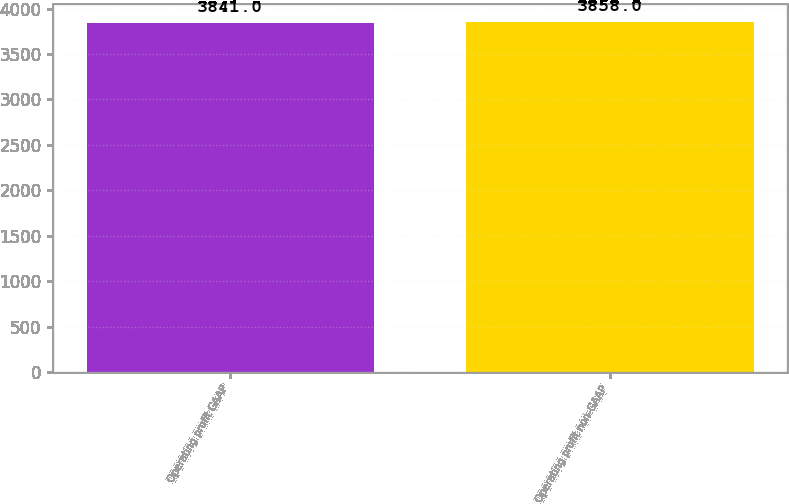<chart> <loc_0><loc_0><loc_500><loc_500><bar_chart><fcel>Operating profit GAAP<fcel>Operating profit non-GAAP<nl><fcel>3841<fcel>3858<nl></chart> 